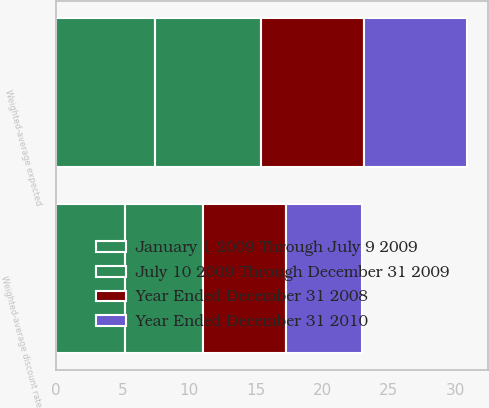Convert chart. <chart><loc_0><loc_0><loc_500><loc_500><stacked_bar_chart><ecel><fcel>Weighted-average expected<fcel>Weighted-average discount rate<nl><fcel>January 1 2009 Through July 9 2009<fcel>7.42<fcel>5.19<nl><fcel>July 10 2009 Through December 31 2009<fcel>7.97<fcel>5.82<nl><fcel>Year Ended December 31 2008<fcel>7.74<fcel>6.23<nl><fcel>Year Ended December 31 2010<fcel>7.78<fcel>5.77<nl></chart> 